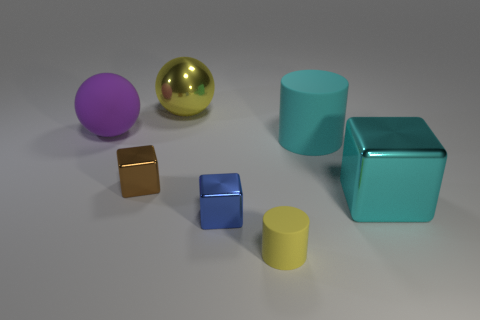Do the yellow rubber object and the purple sphere have the same size?
Keep it short and to the point. No. How many cyan blocks have the same material as the large yellow ball?
Your answer should be compact. 1. There is a ball in front of the shiny object behind the purple matte thing; how big is it?
Keep it short and to the point. Large. There is a object that is both to the left of the large yellow sphere and behind the big cyan cylinder; what is its color?
Offer a very short reply. Purple. Is the shape of the yellow shiny object the same as the purple thing?
Offer a very short reply. Yes. What is the size of the cylinder that is the same color as the large metal ball?
Provide a short and direct response. Small. What is the shape of the big rubber object on the left side of the tiny thing on the right side of the small blue block?
Your answer should be compact. Sphere. There is a yellow metal thing; does it have the same shape as the big matte object to the left of the big rubber cylinder?
Your answer should be very brief. Yes. What color is the other ball that is the same size as the matte ball?
Provide a succinct answer. Yellow. Is the number of tiny objects on the left side of the tiny yellow cylinder less than the number of metallic things that are left of the big matte cylinder?
Provide a succinct answer. Yes. 